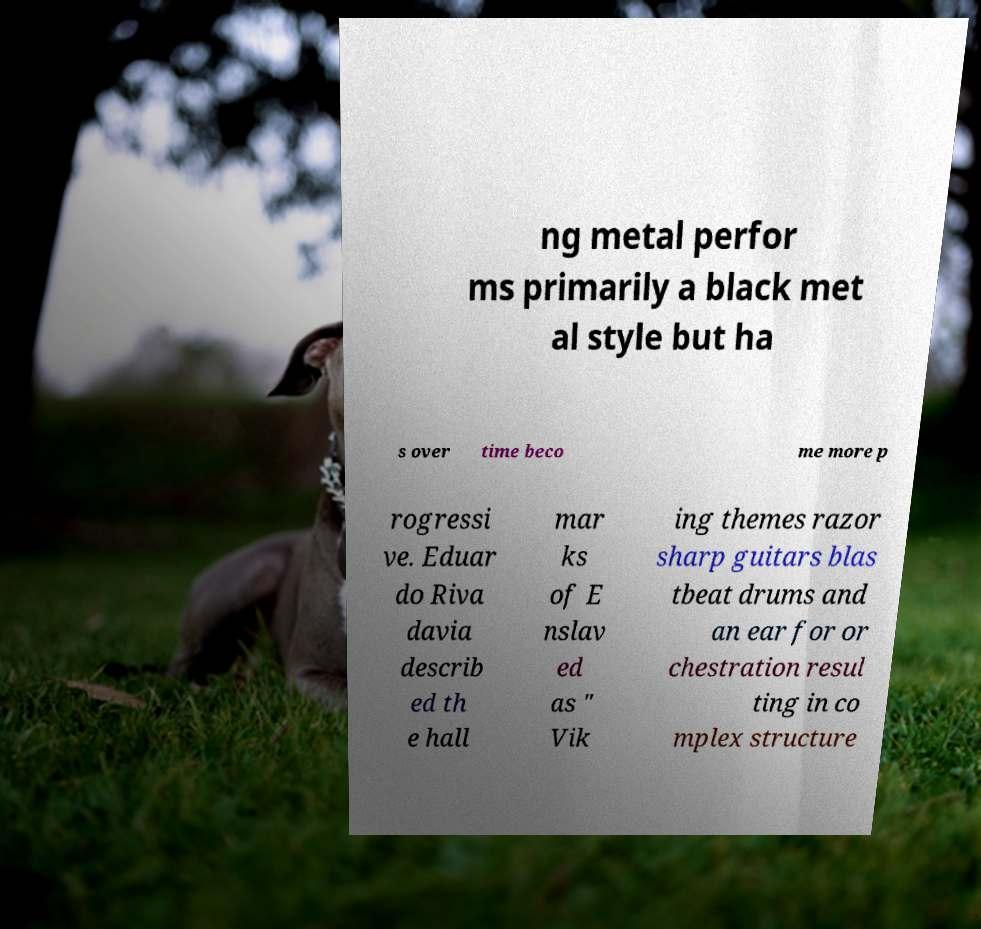Can you accurately transcribe the text from the provided image for me? ng metal perfor ms primarily a black met al style but ha s over time beco me more p rogressi ve. Eduar do Riva davia describ ed th e hall mar ks of E nslav ed as " Vik ing themes razor sharp guitars blas tbeat drums and an ear for or chestration resul ting in co mplex structure 